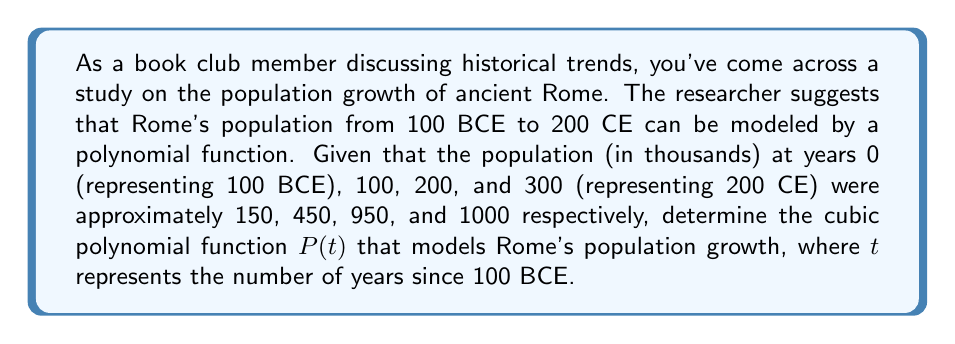Solve this math problem. To find the cubic polynomial function $P(t)$ that models Rome's population growth, we'll use the general form of a cubic polynomial:

$$P(t) = at^3 + bt^2 + ct + d$$

We have four data points:
1. $P(0) = 150$
2. $P(100) = 450$
3. $P(200) = 950$
4. $P(300) = 1000$

Let's substitute these points into the general equation:

1. $150 = a(0)^3 + b(0)^2 + c(0) + d$
   $150 = d$

2. $450 = a(100)^3 + b(100)^2 + c(100) + 150$
   $450 = 1,000,000a + 10,000b + 100c + 150$

3. $950 = a(200)^3 + b(200)^2 + c(200) + 150$
   $950 = 8,000,000a + 40,000b + 200c + 150$

4. $1000 = a(300)^3 + b(300)^2 + c(300) + 150$
   $1000 = 27,000,000a + 90,000b + 300c + 150$

Now we have a system of equations:

$$\begin{cases}
1,000,000a + 10,000b + 100c = 300 \\
8,000,000a + 40,000b + 200c = 800 \\
27,000,000a + 90,000b + 300c = 850
\end{cases}$$

Solving this system (using a method like Gaussian elimination or a computer algebra system) gives us:

$$\begin{align}
a &= -\frac{1}{300,000} \approx -0.00000333 \\
b &= \frac{1}{1,000} = 0.001 \\
c &= \frac{10}{3} \approx 3.333
\end{align}$$

Substituting these values and $d = 150$ into our original equation:

$$P(t) = -\frac{1}{300,000}t^3 + 0.001t^2 + \frac{10}{3}t + 150$$
Answer: $$P(t) = -\frac{1}{300,000}t^3 + 0.001t^2 + \frac{10}{3}t + 150$$ 